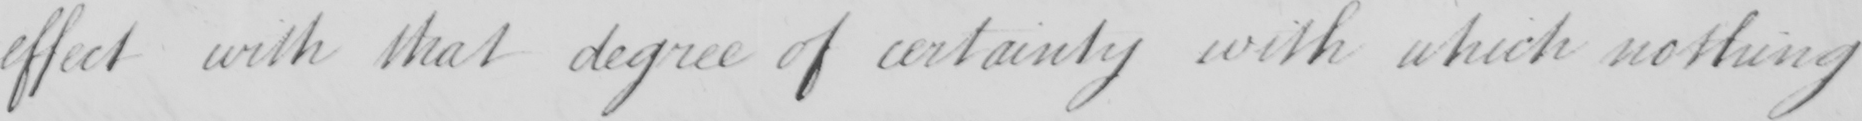Transcribe the text shown in this historical manuscript line. effect with that degree of certainty with which nothing 